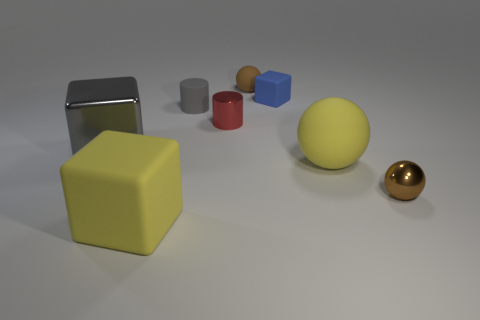Add 2 tiny brown shiny spheres. How many objects exist? 10 Subtract all cylinders. How many objects are left? 6 Subtract 1 gray cylinders. How many objects are left? 7 Subtract all big green spheres. Subtract all small metallic things. How many objects are left? 6 Add 4 tiny red metal objects. How many tiny red metal objects are left? 5 Add 2 red shiny objects. How many red shiny objects exist? 3 